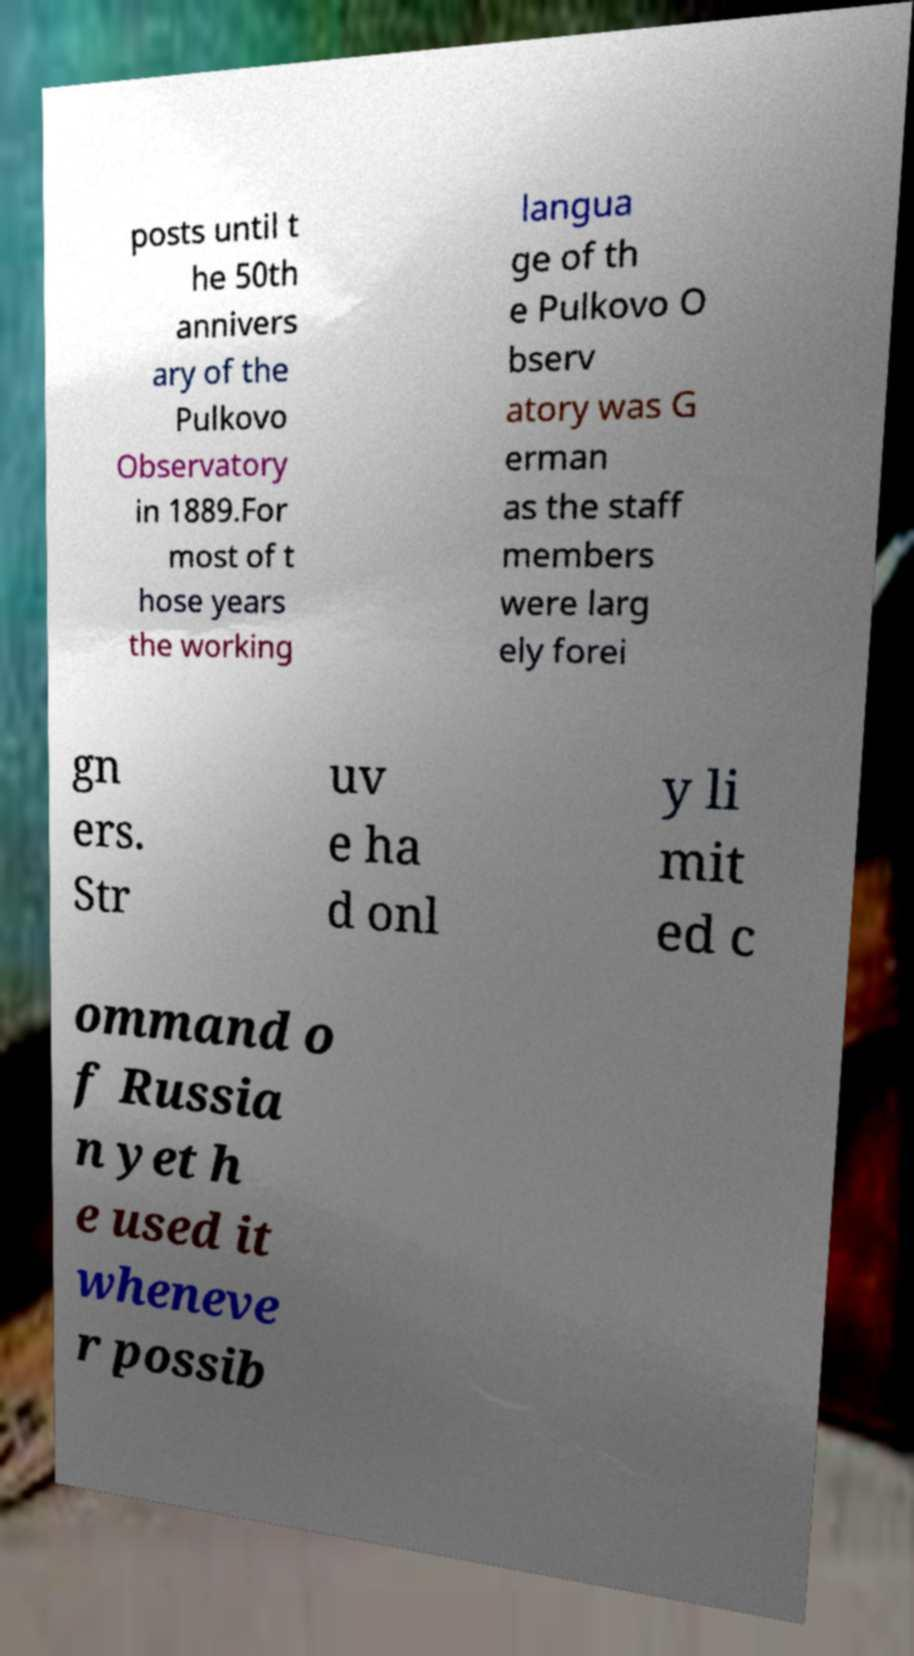Can you accurately transcribe the text from the provided image for me? posts until t he 50th annivers ary of the Pulkovo Observatory in 1889.For most of t hose years the working langua ge of th e Pulkovo O bserv atory was G erman as the staff members were larg ely forei gn ers. Str uv e ha d onl y li mit ed c ommand o f Russia n yet h e used it wheneve r possib 